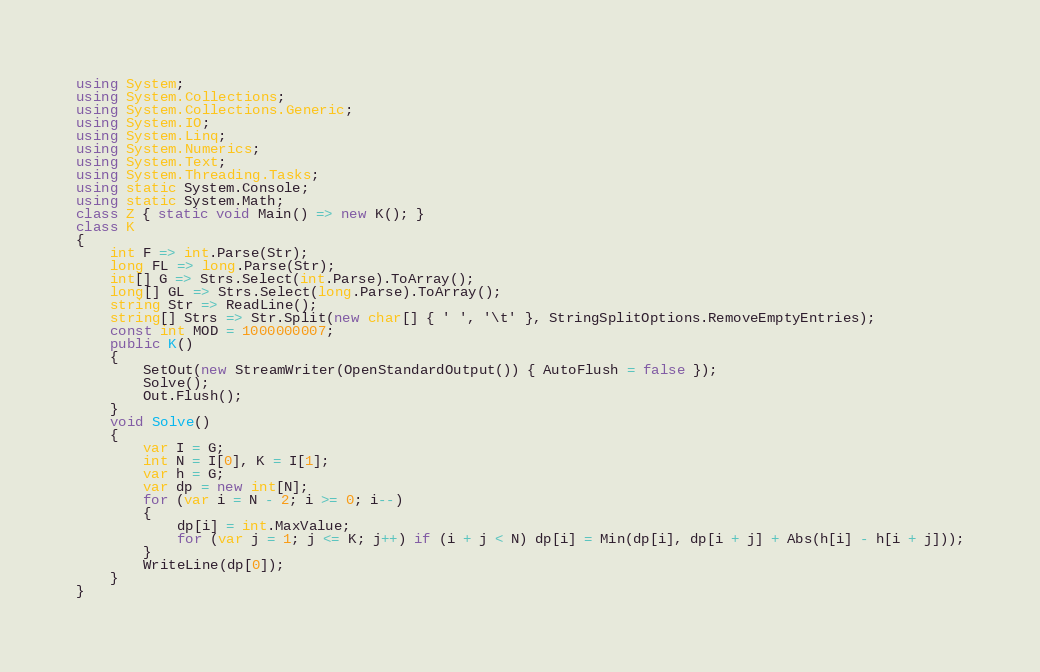Convert code to text. <code><loc_0><loc_0><loc_500><loc_500><_C#_>using System;
using System.Collections;
using System.Collections.Generic;
using System.IO;
using System.Linq;
using System.Numerics;
using System.Text;
using System.Threading.Tasks;
using static System.Console;
using static System.Math;
class Z { static void Main() => new K(); }
class K
{
	int F => int.Parse(Str);
	long FL => long.Parse(Str);
	int[] G => Strs.Select(int.Parse).ToArray();
	long[] GL => Strs.Select(long.Parse).ToArray();
	string Str => ReadLine();
	string[] Strs => Str.Split(new char[] { ' ', '\t' }, StringSplitOptions.RemoveEmptyEntries);
	const int MOD = 1000000007;
	public K()
	{
		SetOut(new StreamWriter(OpenStandardOutput()) { AutoFlush = false });
		Solve();
		Out.Flush();
	}
	void Solve()
	{
		var I = G;
		int N = I[0], K = I[1];
		var h = G;
		var dp = new int[N];
		for (var i = N - 2; i >= 0; i--)
		{
			dp[i] = int.MaxValue;
			for (var j = 1; j <= K; j++) if (i + j < N) dp[i] = Min(dp[i], dp[i + j] + Abs(h[i] - h[i + j]));
		}
		WriteLine(dp[0]);
	}
}
</code> 